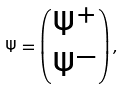<formula> <loc_0><loc_0><loc_500><loc_500>\Psi = \begin{pmatrix} \Psi ^ { + } \\ \Psi ^ { - } \end{pmatrix} ,</formula> 